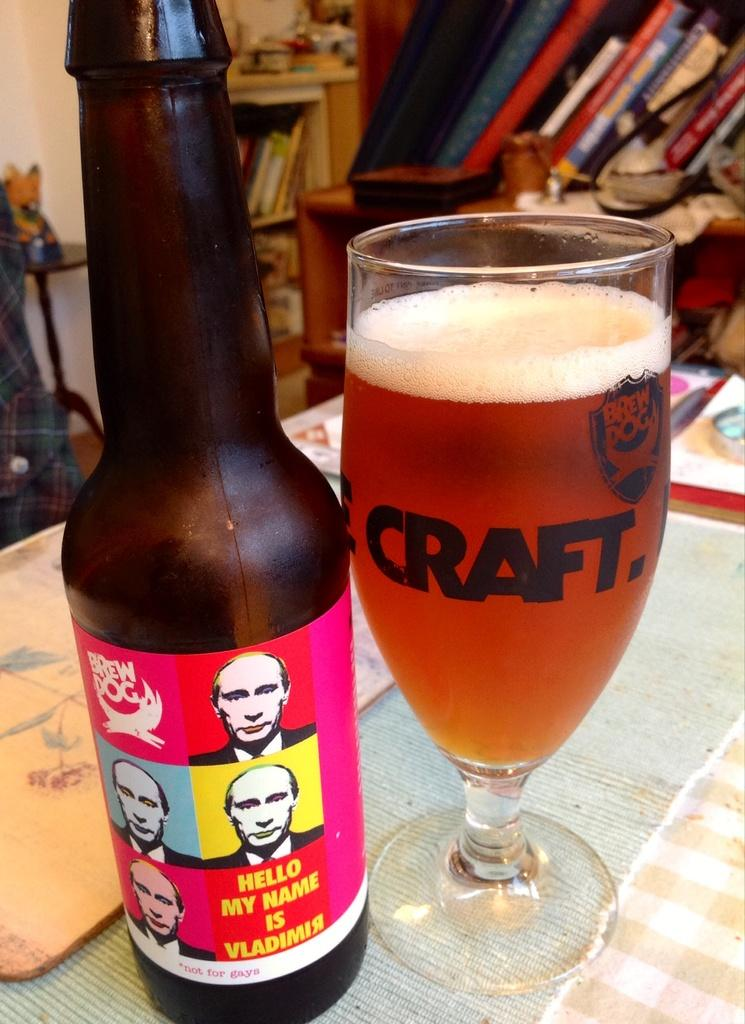<image>
Provide a brief description of the given image. A Brew Dog beer bottle label says "Hello My Name is Vladimir" and the botle sits next to a glass that says Craft. 